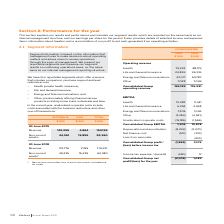From Iselect's financial document, What are the four reportable segments which offer a service that includes comparison, purchase support and lead referrals? The document contains multiple relevant values: Health (private health insurance), Life and General Insurance, Energy and Telecommunications, Other, predominately offering financial service products including home loans in Australia and Asia. From the document: "• Health (private health insurance), Life and General Insurance 24,826 26,916 Energy and Telecommunications 43,071 54,787 • Other, predominately offer..." Also, What do the unalloacated corporate costs include in the current year? costs associated with the business restructure and other one-off transactions. The document states: "current year, unallocated corporate costs include costs associated with the business restructure and other one-off transactions...." Also, What is the revenue in Australia in 2019? According to the financial document, 149,295 (in thousands). The relevant text states: "Revenue 149,295 4,864 154,159..." Also, can you calculate: What is the percentage change in the revenue in Australia from 2018 to 2019? To answer this question, I need to perform calculations using the financial data. The calculation is: (149,295-174,776)/174,776, which equals -14.58 (percentage). This is based on the information: "Revenue 149,295 4,864 154,159 Revenue 174,776 2,155 176,931..." The key data points involved are: 149,295, 174,776. Also, can you calculate: What is the percentage change in the revenue in Asia from 2018 to 2019? To answer this question, I need to perform calculations using the financial data. The calculation is: (4,864-2,155)/2,155, which equals 125.71 (percentage). This is based on the information: "Revenue 149,295 4,864 154,159 Revenue 174,776 2,155 176,931..." The key data points involved are: 2,155, 4,864. Also, can you calculate: What is the percentage of Australia's non-current assets in the total non-current assets in 2019? Based on the calculation: 44,061/59,960, the result is 73.48 (percentage). This is based on the information: "Non-current assets 1 44,061 15,899 59,960 Non-current assets 1 44,061 15,899 59,960..." The key data points involved are: 44,061, 59,960. 